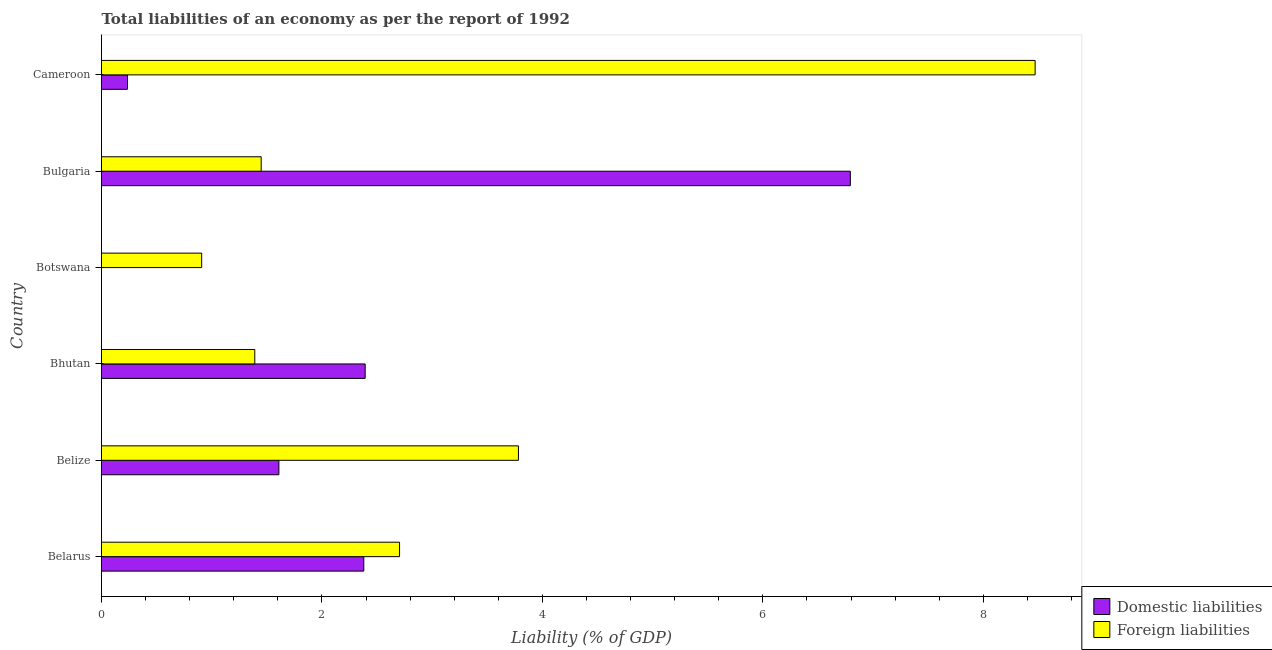How many different coloured bars are there?
Make the answer very short. 2. Are the number of bars per tick equal to the number of legend labels?
Keep it short and to the point. No. How many bars are there on the 4th tick from the top?
Provide a short and direct response. 2. What is the label of the 6th group of bars from the top?
Your answer should be very brief. Belarus. In how many cases, is the number of bars for a given country not equal to the number of legend labels?
Offer a very short reply. 1. What is the incurrence of foreign liabilities in Bulgaria?
Ensure brevity in your answer.  1.45. Across all countries, what is the maximum incurrence of domestic liabilities?
Offer a terse response. 6.79. Across all countries, what is the minimum incurrence of foreign liabilities?
Provide a succinct answer. 0.91. In which country was the incurrence of foreign liabilities maximum?
Offer a terse response. Cameroon. What is the total incurrence of domestic liabilities in the graph?
Ensure brevity in your answer.  13.41. What is the difference between the incurrence of foreign liabilities in Belarus and that in Belize?
Provide a succinct answer. -1.08. What is the difference between the incurrence of foreign liabilities in Botswana and the incurrence of domestic liabilities in Bulgaria?
Keep it short and to the point. -5.89. What is the average incurrence of foreign liabilities per country?
Offer a very short reply. 3.12. What is the ratio of the incurrence of domestic liabilities in Belize to that in Cameroon?
Provide a short and direct response. 6.82. Is the incurrence of foreign liabilities in Bhutan less than that in Cameroon?
Ensure brevity in your answer.  Yes. What is the difference between the highest and the second highest incurrence of domestic liabilities?
Offer a very short reply. 4.4. What is the difference between the highest and the lowest incurrence of foreign liabilities?
Offer a very short reply. 7.56. Are all the bars in the graph horizontal?
Provide a short and direct response. Yes. How many countries are there in the graph?
Offer a very short reply. 6. What is the difference between two consecutive major ticks on the X-axis?
Give a very brief answer. 2. Does the graph contain any zero values?
Offer a very short reply. Yes. Where does the legend appear in the graph?
Your answer should be very brief. Bottom right. How many legend labels are there?
Your answer should be compact. 2. How are the legend labels stacked?
Keep it short and to the point. Vertical. What is the title of the graph?
Your answer should be very brief. Total liabilities of an economy as per the report of 1992. What is the label or title of the X-axis?
Provide a succinct answer. Liability (% of GDP). What is the label or title of the Y-axis?
Keep it short and to the point. Country. What is the Liability (% of GDP) in Domestic liabilities in Belarus?
Make the answer very short. 2.38. What is the Liability (% of GDP) in Foreign liabilities in Belarus?
Give a very brief answer. 2.7. What is the Liability (% of GDP) of Domestic liabilities in Belize?
Provide a succinct answer. 1.61. What is the Liability (% of GDP) of Foreign liabilities in Belize?
Ensure brevity in your answer.  3.78. What is the Liability (% of GDP) in Domestic liabilities in Bhutan?
Offer a very short reply. 2.39. What is the Liability (% of GDP) in Foreign liabilities in Bhutan?
Your answer should be compact. 1.39. What is the Liability (% of GDP) in Foreign liabilities in Botswana?
Your response must be concise. 0.91. What is the Liability (% of GDP) of Domestic liabilities in Bulgaria?
Your answer should be compact. 6.79. What is the Liability (% of GDP) in Foreign liabilities in Bulgaria?
Your answer should be compact. 1.45. What is the Liability (% of GDP) of Domestic liabilities in Cameroon?
Keep it short and to the point. 0.24. What is the Liability (% of GDP) of Foreign liabilities in Cameroon?
Offer a terse response. 8.47. Across all countries, what is the maximum Liability (% of GDP) in Domestic liabilities?
Give a very brief answer. 6.79. Across all countries, what is the maximum Liability (% of GDP) of Foreign liabilities?
Provide a short and direct response. 8.47. Across all countries, what is the minimum Liability (% of GDP) of Domestic liabilities?
Make the answer very short. 0. Across all countries, what is the minimum Liability (% of GDP) in Foreign liabilities?
Ensure brevity in your answer.  0.91. What is the total Liability (% of GDP) of Domestic liabilities in the graph?
Give a very brief answer. 13.41. What is the total Liability (% of GDP) of Foreign liabilities in the graph?
Provide a short and direct response. 18.71. What is the difference between the Liability (% of GDP) of Domestic liabilities in Belarus and that in Belize?
Make the answer very short. 0.77. What is the difference between the Liability (% of GDP) of Foreign liabilities in Belarus and that in Belize?
Your response must be concise. -1.08. What is the difference between the Liability (% of GDP) in Domestic liabilities in Belarus and that in Bhutan?
Offer a very short reply. -0.01. What is the difference between the Liability (% of GDP) in Foreign liabilities in Belarus and that in Bhutan?
Keep it short and to the point. 1.31. What is the difference between the Liability (% of GDP) in Foreign liabilities in Belarus and that in Botswana?
Give a very brief answer. 1.8. What is the difference between the Liability (% of GDP) in Domestic liabilities in Belarus and that in Bulgaria?
Offer a very short reply. -4.41. What is the difference between the Liability (% of GDP) in Foreign liabilities in Belarus and that in Bulgaria?
Make the answer very short. 1.26. What is the difference between the Liability (% of GDP) of Domestic liabilities in Belarus and that in Cameroon?
Offer a terse response. 2.14. What is the difference between the Liability (% of GDP) of Foreign liabilities in Belarus and that in Cameroon?
Give a very brief answer. -5.77. What is the difference between the Liability (% of GDP) of Domestic liabilities in Belize and that in Bhutan?
Provide a short and direct response. -0.78. What is the difference between the Liability (% of GDP) in Foreign liabilities in Belize and that in Bhutan?
Keep it short and to the point. 2.39. What is the difference between the Liability (% of GDP) in Foreign liabilities in Belize and that in Botswana?
Your response must be concise. 2.87. What is the difference between the Liability (% of GDP) of Domestic liabilities in Belize and that in Bulgaria?
Keep it short and to the point. -5.18. What is the difference between the Liability (% of GDP) in Foreign liabilities in Belize and that in Bulgaria?
Your response must be concise. 2.33. What is the difference between the Liability (% of GDP) of Domestic liabilities in Belize and that in Cameroon?
Provide a succinct answer. 1.37. What is the difference between the Liability (% of GDP) of Foreign liabilities in Belize and that in Cameroon?
Offer a terse response. -4.69. What is the difference between the Liability (% of GDP) of Foreign liabilities in Bhutan and that in Botswana?
Give a very brief answer. 0.48. What is the difference between the Liability (% of GDP) of Domestic liabilities in Bhutan and that in Bulgaria?
Your answer should be very brief. -4.4. What is the difference between the Liability (% of GDP) of Foreign liabilities in Bhutan and that in Bulgaria?
Your answer should be compact. -0.06. What is the difference between the Liability (% of GDP) in Domestic liabilities in Bhutan and that in Cameroon?
Offer a very short reply. 2.16. What is the difference between the Liability (% of GDP) of Foreign liabilities in Bhutan and that in Cameroon?
Ensure brevity in your answer.  -7.08. What is the difference between the Liability (% of GDP) of Foreign liabilities in Botswana and that in Bulgaria?
Offer a very short reply. -0.54. What is the difference between the Liability (% of GDP) of Foreign liabilities in Botswana and that in Cameroon?
Ensure brevity in your answer.  -7.56. What is the difference between the Liability (% of GDP) of Domestic liabilities in Bulgaria and that in Cameroon?
Offer a very short reply. 6.56. What is the difference between the Liability (% of GDP) in Foreign liabilities in Bulgaria and that in Cameroon?
Your response must be concise. -7.02. What is the difference between the Liability (% of GDP) of Domestic liabilities in Belarus and the Liability (% of GDP) of Foreign liabilities in Belize?
Your answer should be compact. -1.4. What is the difference between the Liability (% of GDP) of Domestic liabilities in Belarus and the Liability (% of GDP) of Foreign liabilities in Botswana?
Make the answer very short. 1.47. What is the difference between the Liability (% of GDP) in Domestic liabilities in Belarus and the Liability (% of GDP) in Foreign liabilities in Cameroon?
Your response must be concise. -6.09. What is the difference between the Liability (% of GDP) in Domestic liabilities in Belize and the Liability (% of GDP) in Foreign liabilities in Bhutan?
Your answer should be very brief. 0.22. What is the difference between the Liability (% of GDP) of Domestic liabilities in Belize and the Liability (% of GDP) of Foreign liabilities in Botswana?
Your response must be concise. 0.7. What is the difference between the Liability (% of GDP) of Domestic liabilities in Belize and the Liability (% of GDP) of Foreign liabilities in Bulgaria?
Ensure brevity in your answer.  0.16. What is the difference between the Liability (% of GDP) in Domestic liabilities in Belize and the Liability (% of GDP) in Foreign liabilities in Cameroon?
Your answer should be compact. -6.86. What is the difference between the Liability (% of GDP) in Domestic liabilities in Bhutan and the Liability (% of GDP) in Foreign liabilities in Botswana?
Make the answer very short. 1.48. What is the difference between the Liability (% of GDP) in Domestic liabilities in Bhutan and the Liability (% of GDP) in Foreign liabilities in Bulgaria?
Provide a succinct answer. 0.94. What is the difference between the Liability (% of GDP) of Domestic liabilities in Bhutan and the Liability (% of GDP) of Foreign liabilities in Cameroon?
Your answer should be very brief. -6.08. What is the difference between the Liability (% of GDP) in Domestic liabilities in Bulgaria and the Liability (% of GDP) in Foreign liabilities in Cameroon?
Make the answer very short. -1.68. What is the average Liability (% of GDP) in Domestic liabilities per country?
Make the answer very short. 2.24. What is the average Liability (% of GDP) of Foreign liabilities per country?
Provide a succinct answer. 3.12. What is the difference between the Liability (% of GDP) of Domestic liabilities and Liability (% of GDP) of Foreign liabilities in Belarus?
Give a very brief answer. -0.32. What is the difference between the Liability (% of GDP) in Domestic liabilities and Liability (% of GDP) in Foreign liabilities in Belize?
Offer a terse response. -2.17. What is the difference between the Liability (% of GDP) in Domestic liabilities and Liability (% of GDP) in Foreign liabilities in Bulgaria?
Offer a terse response. 5.35. What is the difference between the Liability (% of GDP) in Domestic liabilities and Liability (% of GDP) in Foreign liabilities in Cameroon?
Give a very brief answer. -8.23. What is the ratio of the Liability (% of GDP) of Domestic liabilities in Belarus to that in Belize?
Keep it short and to the point. 1.48. What is the ratio of the Liability (% of GDP) of Foreign liabilities in Belarus to that in Belize?
Provide a succinct answer. 0.71. What is the ratio of the Liability (% of GDP) of Foreign liabilities in Belarus to that in Bhutan?
Your answer should be compact. 1.94. What is the ratio of the Liability (% of GDP) in Foreign liabilities in Belarus to that in Botswana?
Keep it short and to the point. 2.98. What is the ratio of the Liability (% of GDP) in Domestic liabilities in Belarus to that in Bulgaria?
Your response must be concise. 0.35. What is the ratio of the Liability (% of GDP) in Foreign liabilities in Belarus to that in Bulgaria?
Provide a short and direct response. 1.87. What is the ratio of the Liability (% of GDP) of Domestic liabilities in Belarus to that in Cameroon?
Provide a succinct answer. 10.08. What is the ratio of the Liability (% of GDP) in Foreign liabilities in Belarus to that in Cameroon?
Offer a very short reply. 0.32. What is the ratio of the Liability (% of GDP) in Domestic liabilities in Belize to that in Bhutan?
Offer a terse response. 0.67. What is the ratio of the Liability (% of GDP) in Foreign liabilities in Belize to that in Bhutan?
Your answer should be compact. 2.72. What is the ratio of the Liability (% of GDP) in Foreign liabilities in Belize to that in Botswana?
Your response must be concise. 4.16. What is the ratio of the Liability (% of GDP) of Domestic liabilities in Belize to that in Bulgaria?
Offer a terse response. 0.24. What is the ratio of the Liability (% of GDP) in Foreign liabilities in Belize to that in Bulgaria?
Give a very brief answer. 2.61. What is the ratio of the Liability (% of GDP) in Domestic liabilities in Belize to that in Cameroon?
Make the answer very short. 6.82. What is the ratio of the Liability (% of GDP) in Foreign liabilities in Belize to that in Cameroon?
Your answer should be compact. 0.45. What is the ratio of the Liability (% of GDP) in Foreign liabilities in Bhutan to that in Botswana?
Ensure brevity in your answer.  1.53. What is the ratio of the Liability (% of GDP) of Domestic liabilities in Bhutan to that in Bulgaria?
Your answer should be very brief. 0.35. What is the ratio of the Liability (% of GDP) in Foreign liabilities in Bhutan to that in Bulgaria?
Provide a short and direct response. 0.96. What is the ratio of the Liability (% of GDP) in Domestic liabilities in Bhutan to that in Cameroon?
Your answer should be compact. 10.14. What is the ratio of the Liability (% of GDP) in Foreign liabilities in Bhutan to that in Cameroon?
Give a very brief answer. 0.16. What is the ratio of the Liability (% of GDP) in Foreign liabilities in Botswana to that in Bulgaria?
Your answer should be compact. 0.63. What is the ratio of the Liability (% of GDP) of Foreign liabilities in Botswana to that in Cameroon?
Give a very brief answer. 0.11. What is the ratio of the Liability (% of GDP) in Domestic liabilities in Bulgaria to that in Cameroon?
Your response must be concise. 28.79. What is the ratio of the Liability (% of GDP) in Foreign liabilities in Bulgaria to that in Cameroon?
Provide a succinct answer. 0.17. What is the difference between the highest and the second highest Liability (% of GDP) in Domestic liabilities?
Offer a terse response. 4.4. What is the difference between the highest and the second highest Liability (% of GDP) in Foreign liabilities?
Your answer should be compact. 4.69. What is the difference between the highest and the lowest Liability (% of GDP) in Domestic liabilities?
Your response must be concise. 6.79. What is the difference between the highest and the lowest Liability (% of GDP) of Foreign liabilities?
Your answer should be very brief. 7.56. 